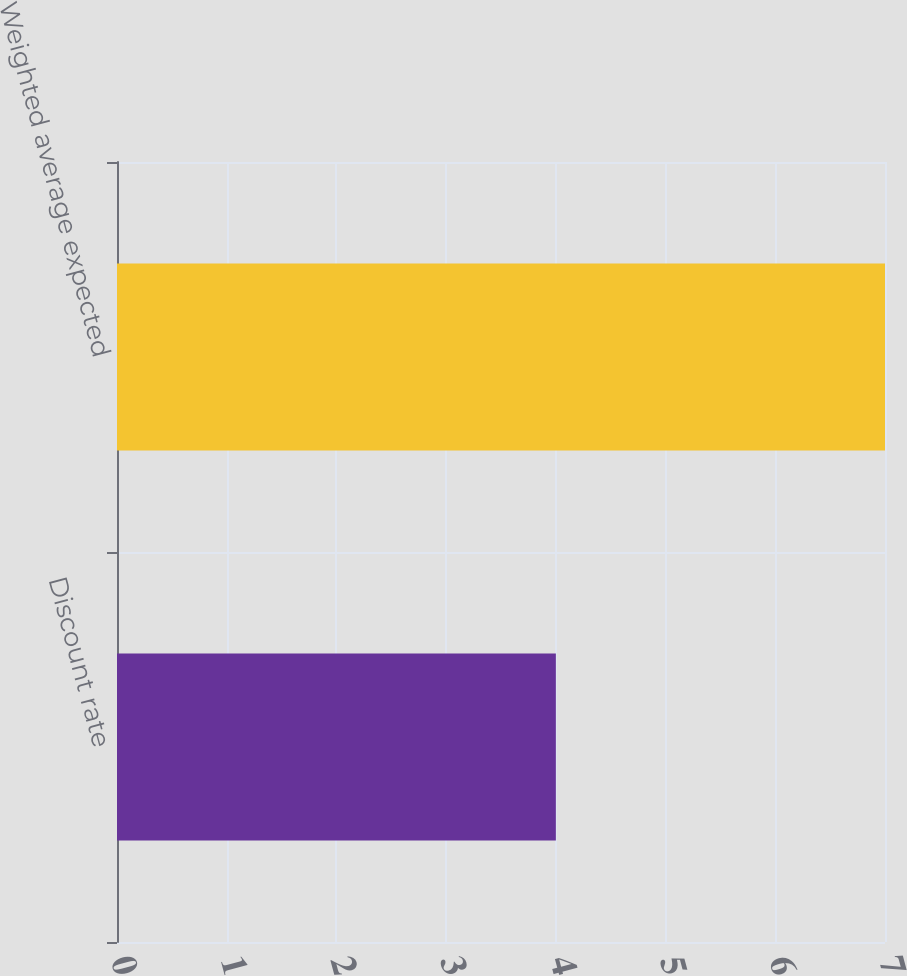<chart> <loc_0><loc_0><loc_500><loc_500><bar_chart><fcel>Discount rate<fcel>Weighted average expected<nl><fcel>4<fcel>7<nl></chart> 